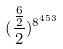<formula> <loc_0><loc_0><loc_500><loc_500>( \frac { \frac { 6 } { 2 } } { 2 } ) ^ { 8 ^ { 4 5 3 } }</formula> 